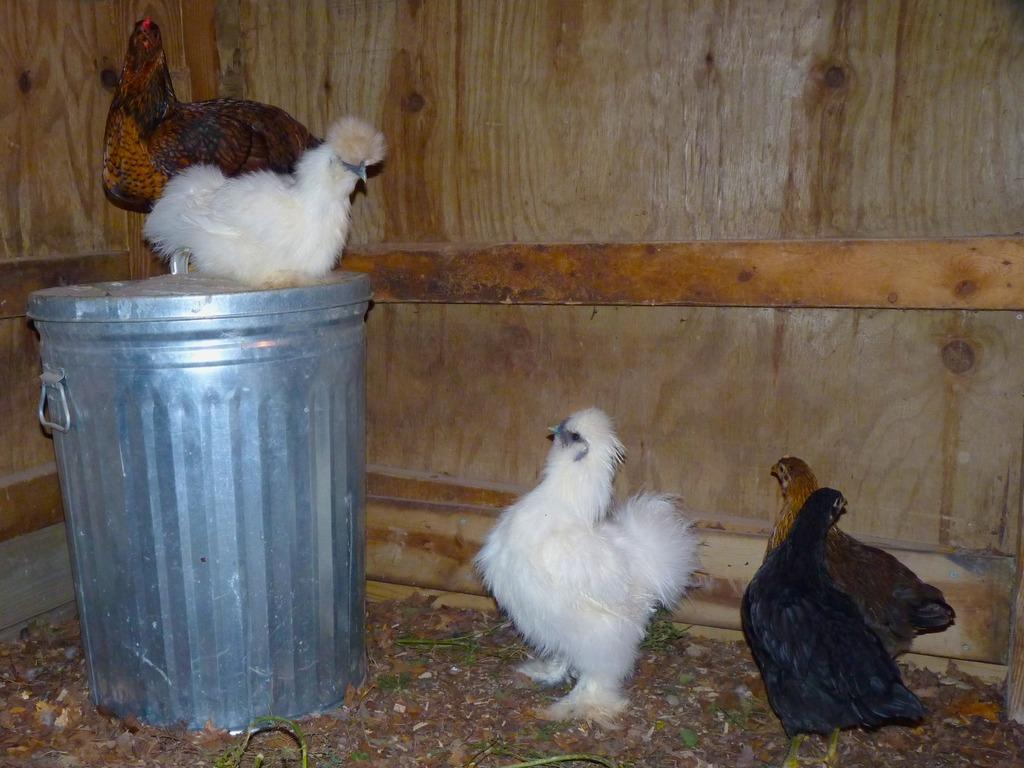What type of animals are present in the image? There are hens in the image. How many hens are on the ground? Three hens are on the ground. How many hens are on a jar? Two hens are on a jar. What type of market is the stranger visiting in the image? There is no market or stranger present in the image; it features hens on the ground and on a jar. 